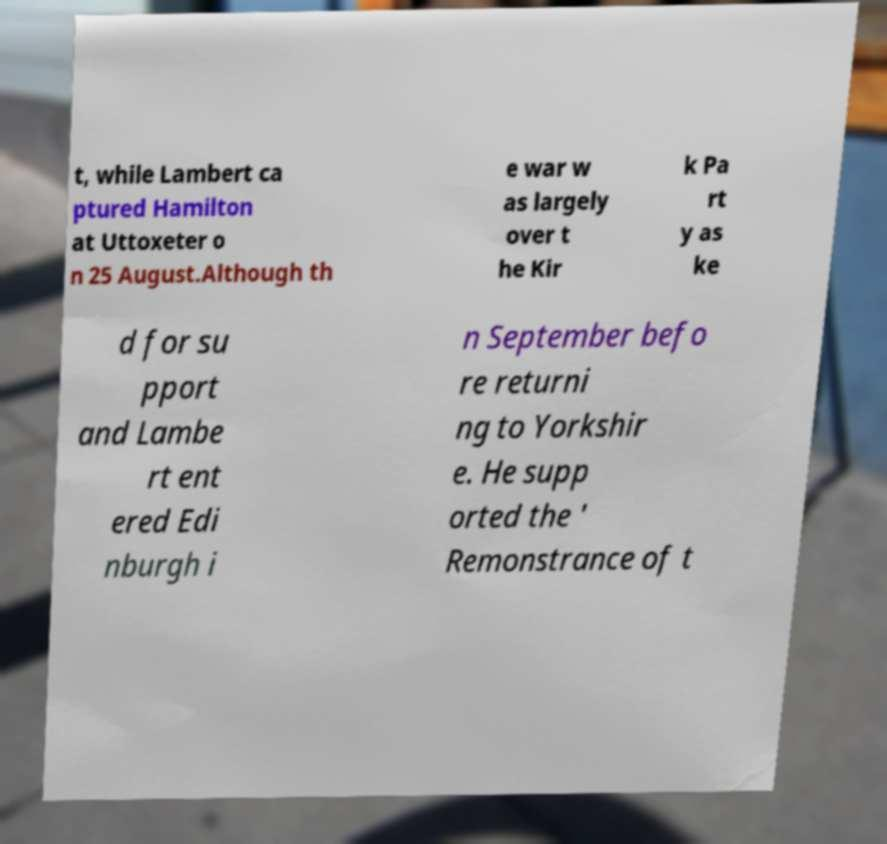Please read and relay the text visible in this image. What does it say? t, while Lambert ca ptured Hamilton at Uttoxeter o n 25 August.Although th e war w as largely over t he Kir k Pa rt y as ke d for su pport and Lambe rt ent ered Edi nburgh i n September befo re returni ng to Yorkshir e. He supp orted the ' Remonstrance of t 